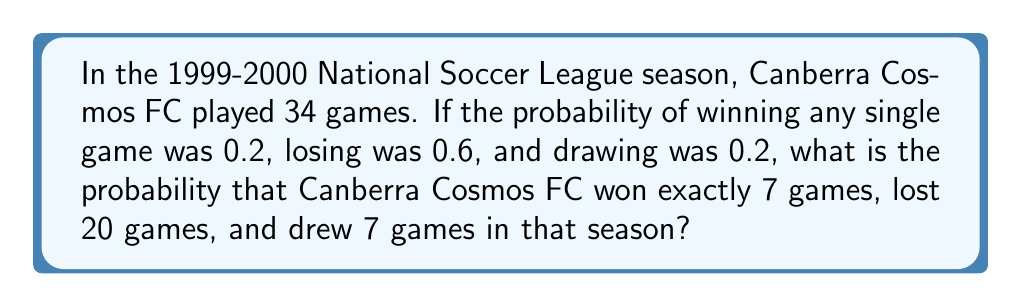Show me your answer to this math problem. Let's approach this step-by-step:

1) This scenario follows a multinomial distribution, where we have three possible outcomes for each game (win, lose, draw) with fixed probabilities.

2) The probability mass function for a multinomial distribution is:

   $$P(X_1 = x_1, X_2 = x_2, ..., X_k = x_k) = \frac{n!}{x_1! x_2! ... x_k!} p_1^{x_1} p_2^{x_2} ... p_k^{x_k}$$

   Where:
   $n$ is the total number of trials (games)
   $x_i$ is the number of times outcome $i$ occurs
   $p_i$ is the probability of outcome $i$

3) In our case:
   $n = 34$ (total games)
   $x_1 = 7$ (wins), $p_1 = 0.2$
   $x_2 = 20$ (losses), $p_2 = 0.6$
   $x_3 = 7$ (draws), $p_3 = 0.2$

4) Plugging these values into the formula:

   $$P(X_1 = 7, X_2 = 20, X_3 = 7) = \frac{34!}{7! 20! 7!} (0.2)^7 (0.6)^{20} (0.2)^7$$

5) Calculating:
   $$\frac{34!}{7! 20! 7!} = 59,144,880$$
   $(0.2)^7 = 1.28 \times 10^{-5}$
   $(0.6)^{20} = 3.66 \times 10^{-5}$
   $(0.2)^7 = 1.28 \times 10^{-5}$

6) Multiplying these together:

   $$59,144,880 \times 1.28 \times 10^{-5} \times 3.66 \times 10^{-5} \times 1.28 \times 10^{-5} \approx 0.00355$$
Answer: $0.00355$ or $0.355\%$ 